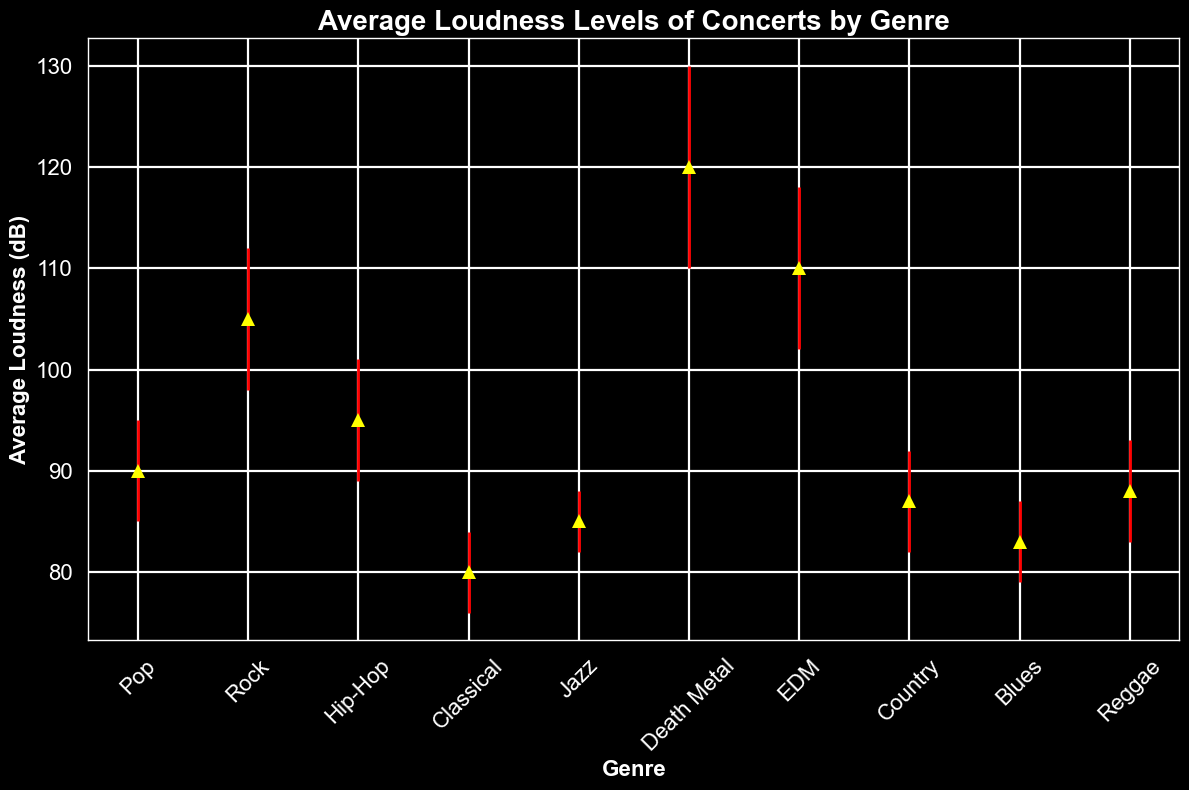What genre has the highest average loudness? First, look at the plot to determine which genre has the highest data point. The highest point is for Death Metal.
Answer: Death Metal Which genre has the lowest average loudness? Examine the plot to find the lowest data point. The lowest point is for Classical.
Answer: Classical How much louder is Rock compared to Pop on average? Note the average loudness levels for Rock (105 dB) and Pop (90 dB). Subtract Pop's loudness from Rock's. 105 dB - 90 dB = 15 dB
Answer: 15 dB Which genres have average loudness levels between 85 dB and 95 dB? Identify the genres with average loudness values within the specified range. Hip-Hop (95 dB), Jazz (85 dB), and Blues (83 dB) fit, but since Blues is slightly below 85 dB, only Hip-Hop and Jazz are within.
Answer: Hip-Hop, Jazz Which genre has the largest error bar and what does this imply? Look at the lengths of the error bars; the largest is for Death Metal, with a 10 dB error. This indicates large venue acoustic variations.
Answer: Death Metal How much louder is EDM compared to Jazz on average, taking into account their maximum error values? EDM has an average loudness of 110 dB with an 8 dB error, so the max could be 118 dB. Jazz has an average of 85 dB with a 3 dB error, so the max could be 88 dB. 118 dB - 88 dB = 30 dB difference.
Answer: 30 dB What is the range of average loudness levels for all genres? Find the lowest and highest average loudness values. Classical is the lowest (80 dB) and Death Metal is the highest (120 dB). The range is 120 dB - 80 dB = 40 dB.
Answer: 40 dB Does any genre have an average loudness with equal or greater uncertainty (error bar) than its average loudness? Compare each genre's average loudness to its error. None has an error equal to or greater than its average loudness.
Answer: No 